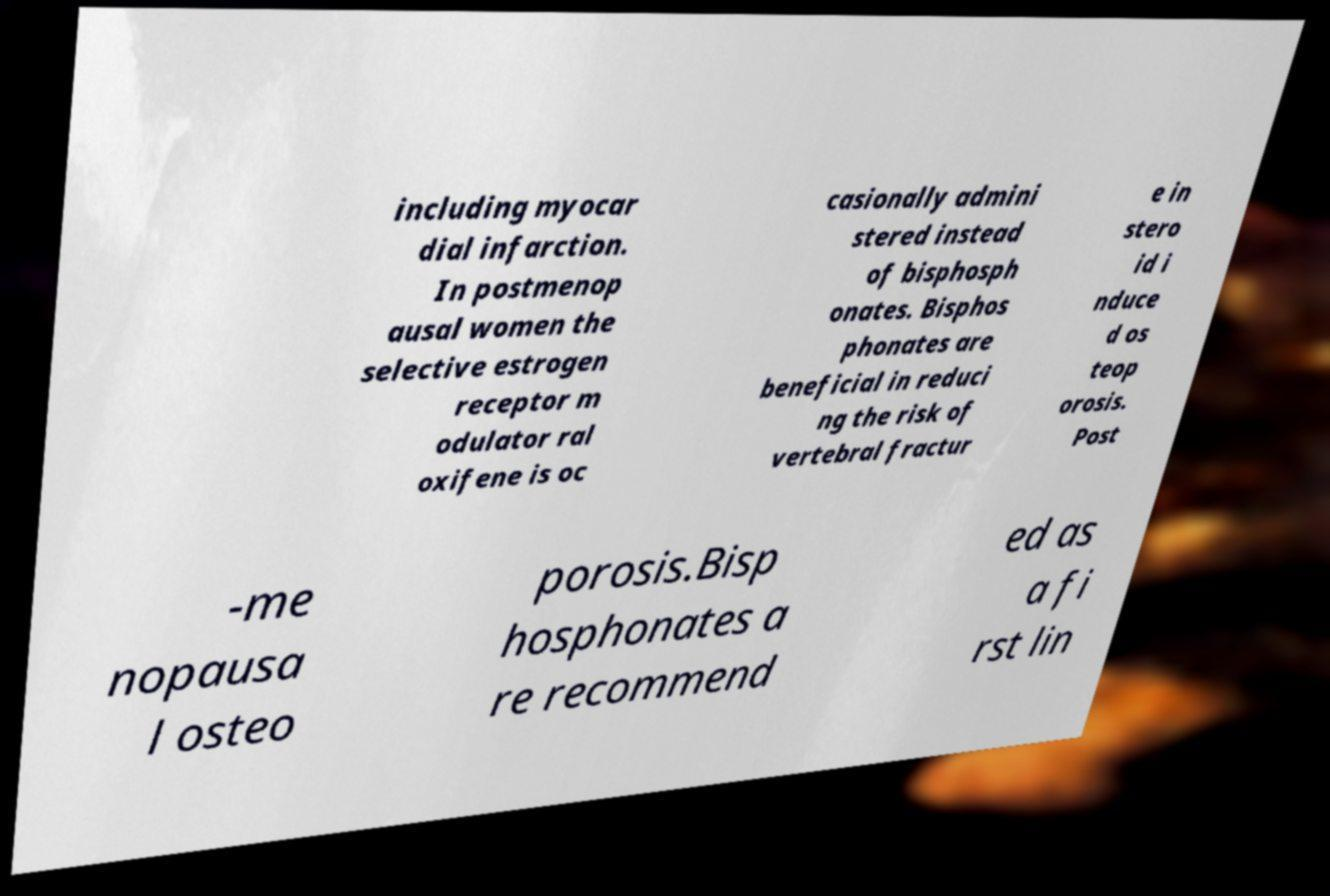Could you extract and type out the text from this image? including myocar dial infarction. In postmenop ausal women the selective estrogen receptor m odulator ral oxifene is oc casionally admini stered instead of bisphosph onates. Bisphos phonates are beneficial in reduci ng the risk of vertebral fractur e in stero id i nduce d os teop orosis. Post -me nopausa l osteo porosis.Bisp hosphonates a re recommend ed as a fi rst lin 